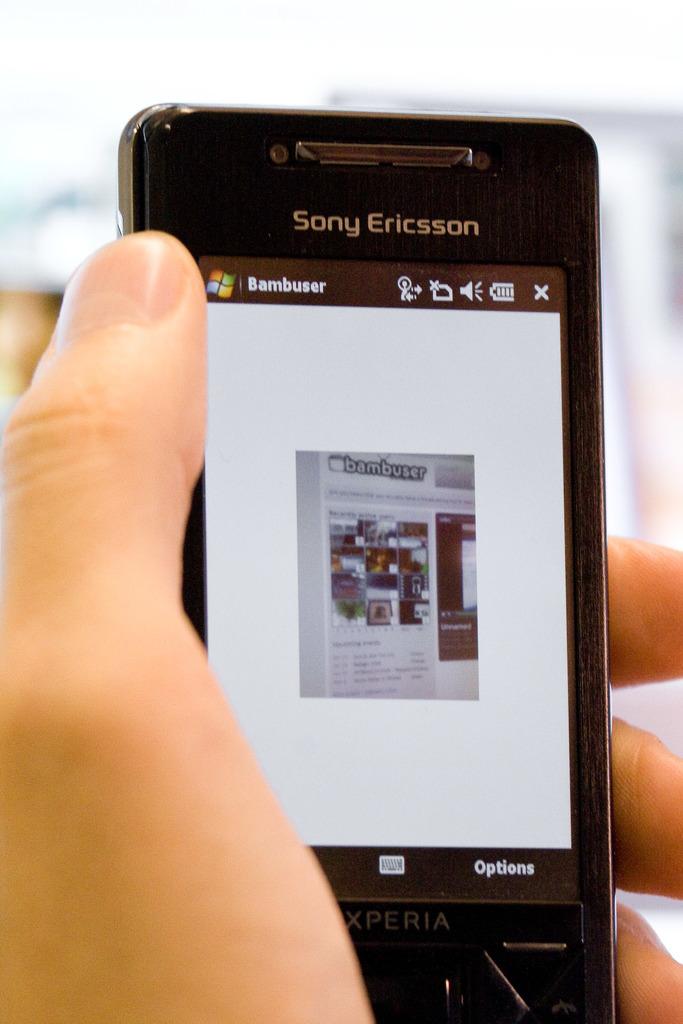Which phone brand is this?
Your response must be concise. Sony ericsson. This mobile windows accsed?
Your answer should be very brief. Yes. 